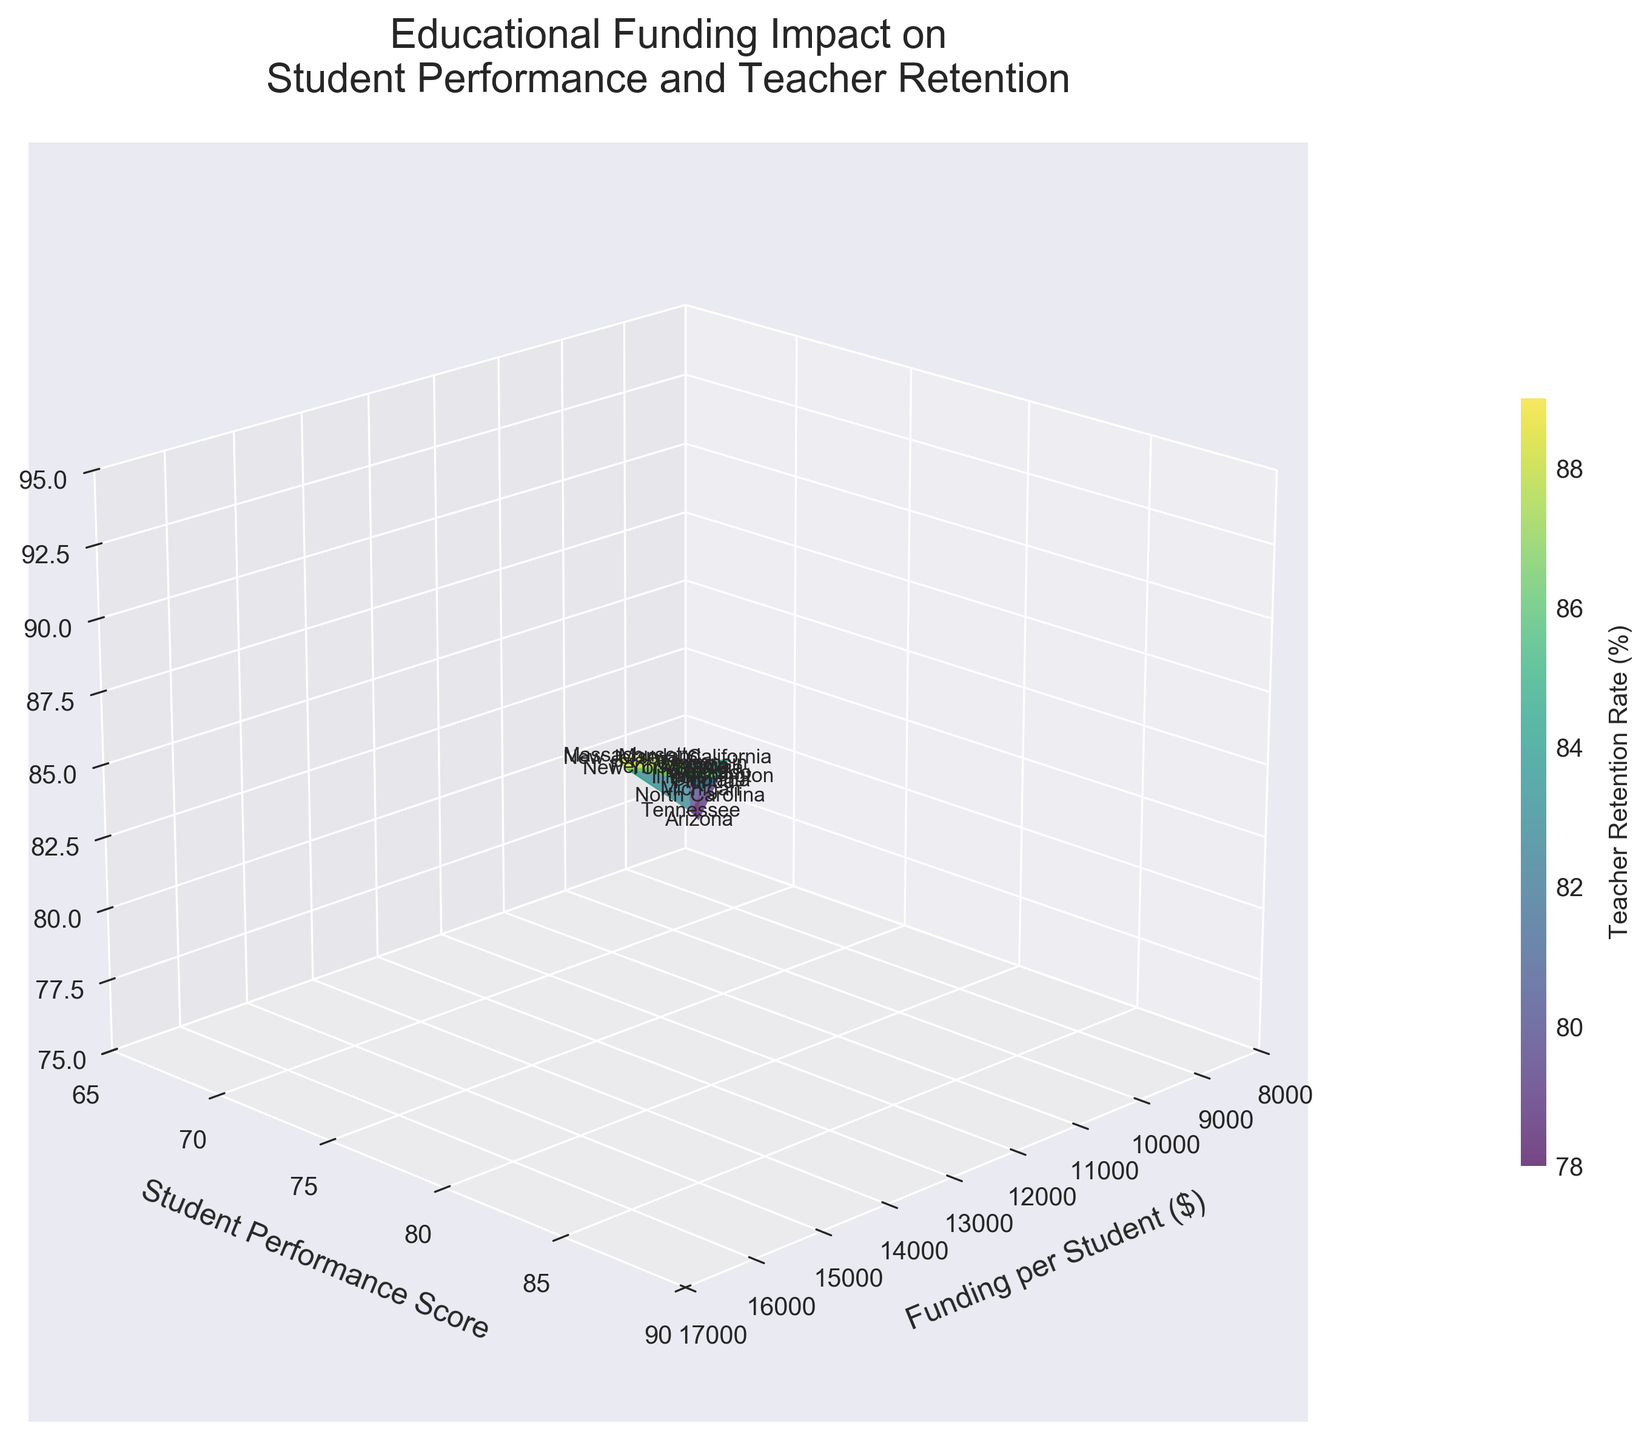What's the title of the plot? The title of the plot is located at the top center of the figure and reads "Educational Funding Impact on Student Performance and Teacher Retention."
Answer: Educational Funding Impact on Student Performance and Teacher Retention What is the color map used in the 3D surface plot? The color map of the 3D surface plot is identified by the gradient of colors displayed on the surface, which is 'viridis' typically ranging from purple to yellow.
Answer: viridis Which state has the highest student performance score? To find the state with the highest student performance score, look at the highest point on the y-axis. Massachusetts has a performance score of 85.
Answer: Massachusetts What state has the lowest funding per student? Observe the lowest value along the x-axis to determine the state. Arizona has the lowest funding per student at $8,500.
Answer: Arizona What is the trend observed between funding per student and student performance score? Examine the general direction of the surface plot from left to right and notice that as funding increases (along the x-axis), student performance scores (along the y-axis) also tend to increase, indicating a positive correlation.
Answer: Positive correlation How does Maryland compare to Pennsylvania in terms of teacher retention rate? Find Maryland and Pennsylvania data points and compare their positions on the z-axis. Both states have a similar teacher retention rate of 88% and 87% respectively.
Answer: Similar What is the average teacher retention rate for states with a student performance score of 80 or above? Identify the states with performance scores of 80 and above, which are Massachusetts, New York, New Jersey, Pennsylvania, Illinois, and Maryland. Their retention rates are 90, 88, 89, 87, 86, and 88. The average is calculated as (90+88+89+87+86+88)/6 = 88
Answer: 88 Which state has a student performance score lower than 70 but a teacher retention rate higher than 75%? Look for states where the y-axis (performance score) is below 70 but the z-axis (retention rate) is above 75%. Arizona, with a score of 67 and retention rate of 77%, fits this criterion.
Answer: Arizona 